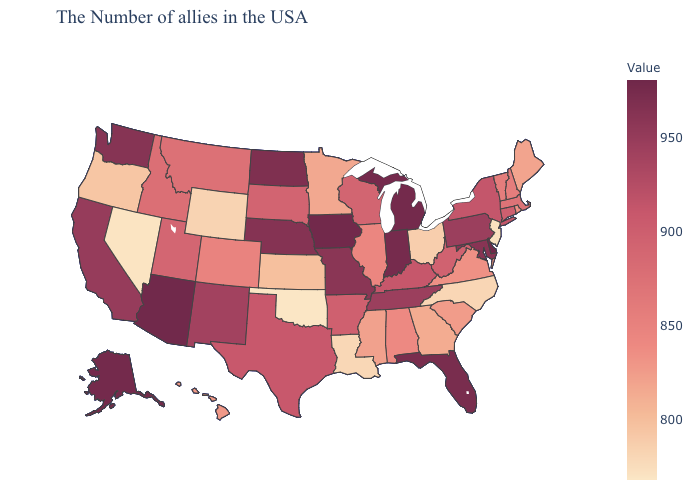Which states have the highest value in the USA?
Keep it brief. Delaware. Among the states that border Arkansas , which have the lowest value?
Be succinct. Oklahoma. Does Oklahoma have the lowest value in the USA?
Concise answer only. Yes. Does the map have missing data?
Write a very short answer. No. Does South Carolina have a lower value than Vermont?
Answer briefly. Yes. Does Delaware have the highest value in the USA?
Answer briefly. Yes. 